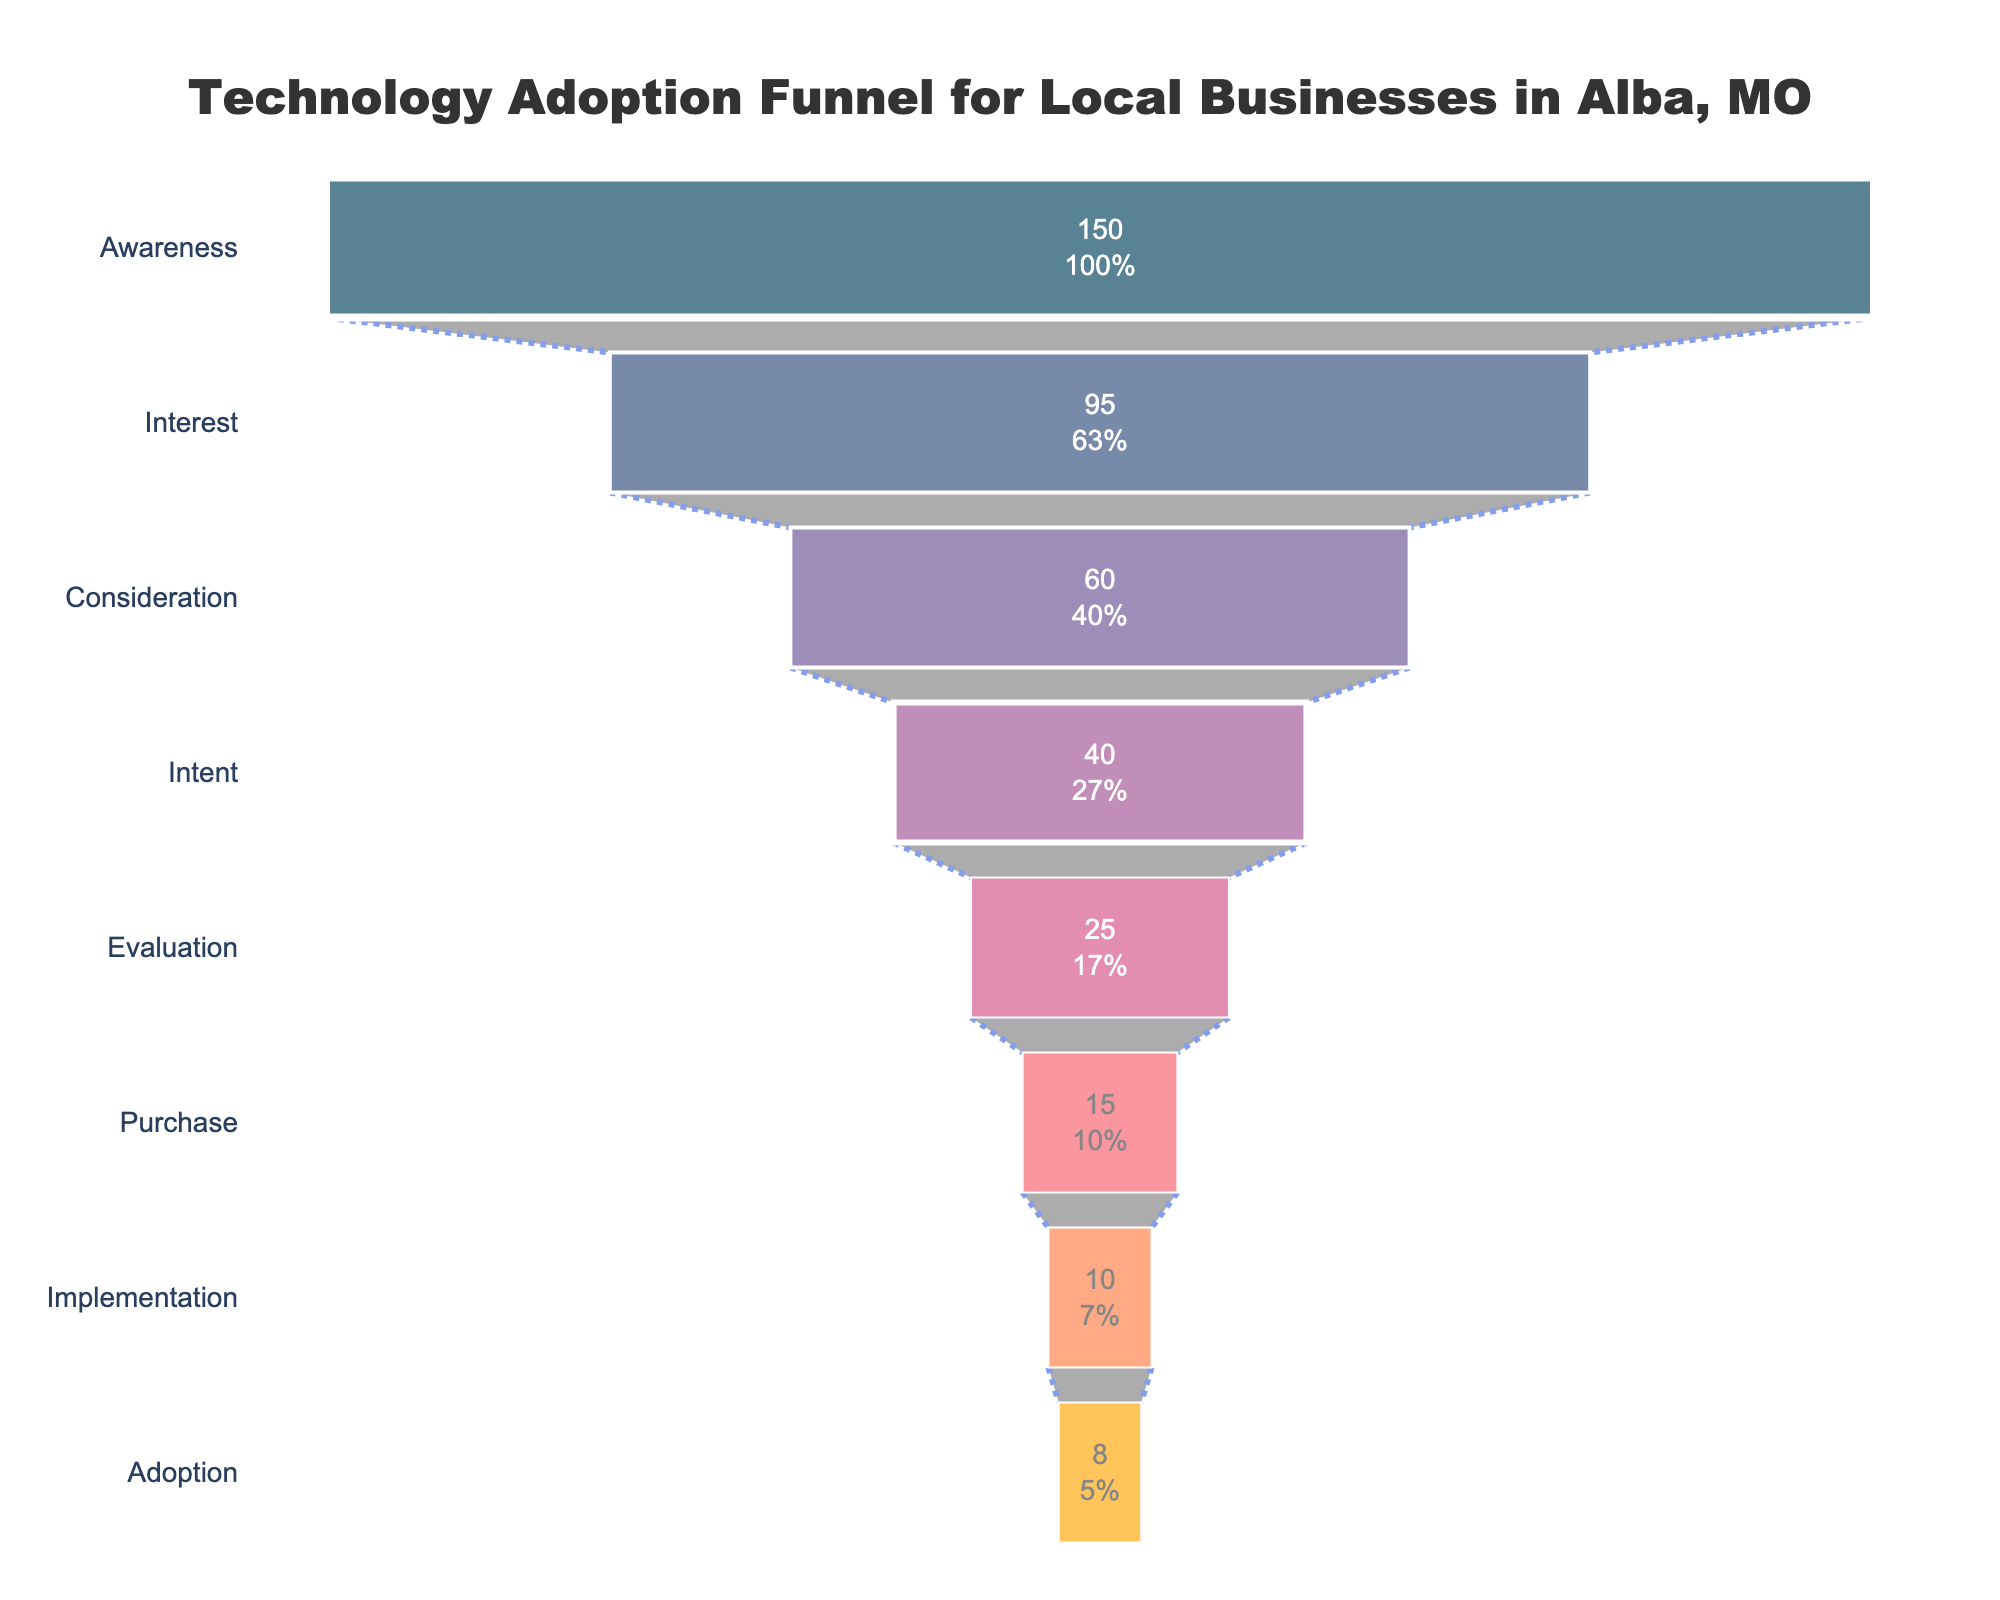What is the title of the funnel chart? The title can be directly read at the top of the chart.
Answer: Technology Adoption Funnel for Local Businesses in Alba, MO How many businesses move from the Consideration stage to the Intent stage? To find the number of businesses moving from the Consideration stage to the Intent stage, subtract the number at the Intent stage (40) from the number at the Consideration stage (60).
Answer: 20 Which stage has the second-highest number of businesses? By observing the values of each stage, the stage with the second-highest number of businesses is Interest with 95.
Answer: Interest What percentage of businesses in the Awareness stage moved to the Interest stage? Calculate the percentage by dividing the number of businesses in the Interest stage (95) by the number in the Awareness stage (150) and then multiplying by 100. (95/150)*100 = 63.33%
Answer: 63.33% Compare the number of businesses in the Evaluation stage to those in the Implementation stage. Which has more businesses? By comparing the values, the Evaluation stage has 25 businesses while the Implementation stage has 10 businesses.
Answer: Evaluation What is the number of stages in the funnel chart? Count the total number of stages.
Answer: 8 What proportion of businesses reached the Adoption stage compared to the Awareness stage? Divide the number of businesses in the Adoption stage (8) by the number in the Awareness stage (150) and convert to a percentage. (8/150)*100 = 5.33%
Answer: 5.33% What is the difference in the number of businesses between the Intent stage and the Purchase stage? Subtract the number of businesses at the Purchase stage (15) from the Intent stage (40).
Answer: 25 Which stage has the smallest number of businesses? By looking at the values in each stage, the Adoption stage has the smallest number of businesses with 8.
Answer: Adoption How many stages have more than 50 businesses? Count the stages where the number of businesses is more than 50. Awareness (150), Interest (95), and Consideration (60) make up 3 stages.
Answer: 3 